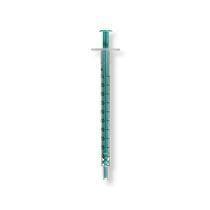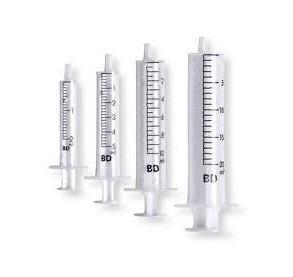The first image is the image on the left, the second image is the image on the right. Examine the images to the left and right. Is the description "Left image shows exactly one syringe-type item, with a green plunger." accurate? Answer yes or no. Yes. The first image is the image on the left, the second image is the image on the right. Analyze the images presented: Is the assertion "There is a single green syringe in the left image" valid? Answer yes or no. Yes. 